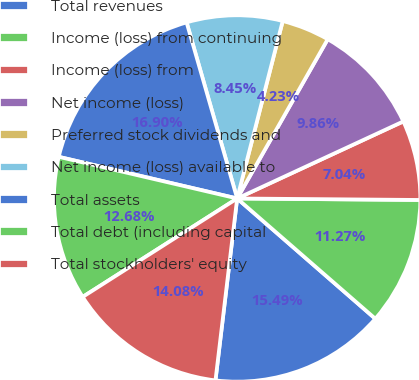Convert chart to OTSL. <chart><loc_0><loc_0><loc_500><loc_500><pie_chart><fcel>Total revenues<fcel>Income (loss) from continuing<fcel>Income (loss) from<fcel>Net income (loss)<fcel>Preferred stock dividends and<fcel>Net income (loss) available to<fcel>Total assets<fcel>Total debt (including capital<fcel>Total stockholders' equity<nl><fcel>15.49%<fcel>11.27%<fcel>7.04%<fcel>9.86%<fcel>4.23%<fcel>8.45%<fcel>16.9%<fcel>12.68%<fcel>14.08%<nl></chart> 